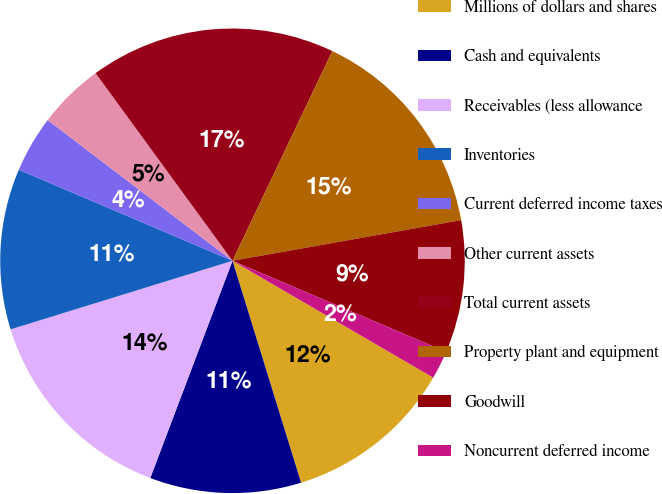Convert chart to OTSL. <chart><loc_0><loc_0><loc_500><loc_500><pie_chart><fcel>Millions of dollars and shares<fcel>Cash and equivalents<fcel>Receivables (less allowance<fcel>Inventories<fcel>Current deferred income taxes<fcel>Other current assets<fcel>Total current assets<fcel>Property plant and equipment<fcel>Goodwill<fcel>Noncurrent deferred income<nl><fcel>11.84%<fcel>10.53%<fcel>14.47%<fcel>11.18%<fcel>3.95%<fcel>4.61%<fcel>17.1%<fcel>15.13%<fcel>9.21%<fcel>1.98%<nl></chart> 